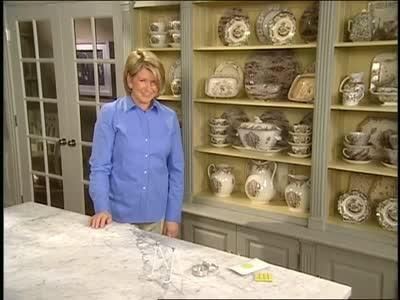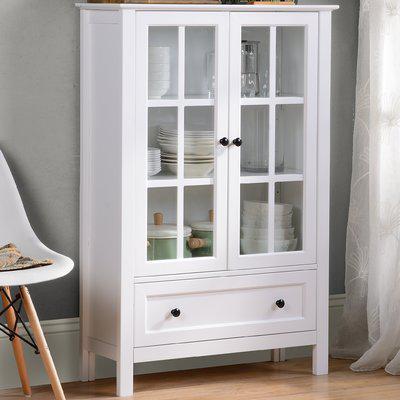The first image is the image on the left, the second image is the image on the right. Evaluate the accuracy of this statement regarding the images: "One cabinet is white with a pale blue interior and sculpted, non-flat top, and sits flush to the floor.". Is it true? Answer yes or no. No. 